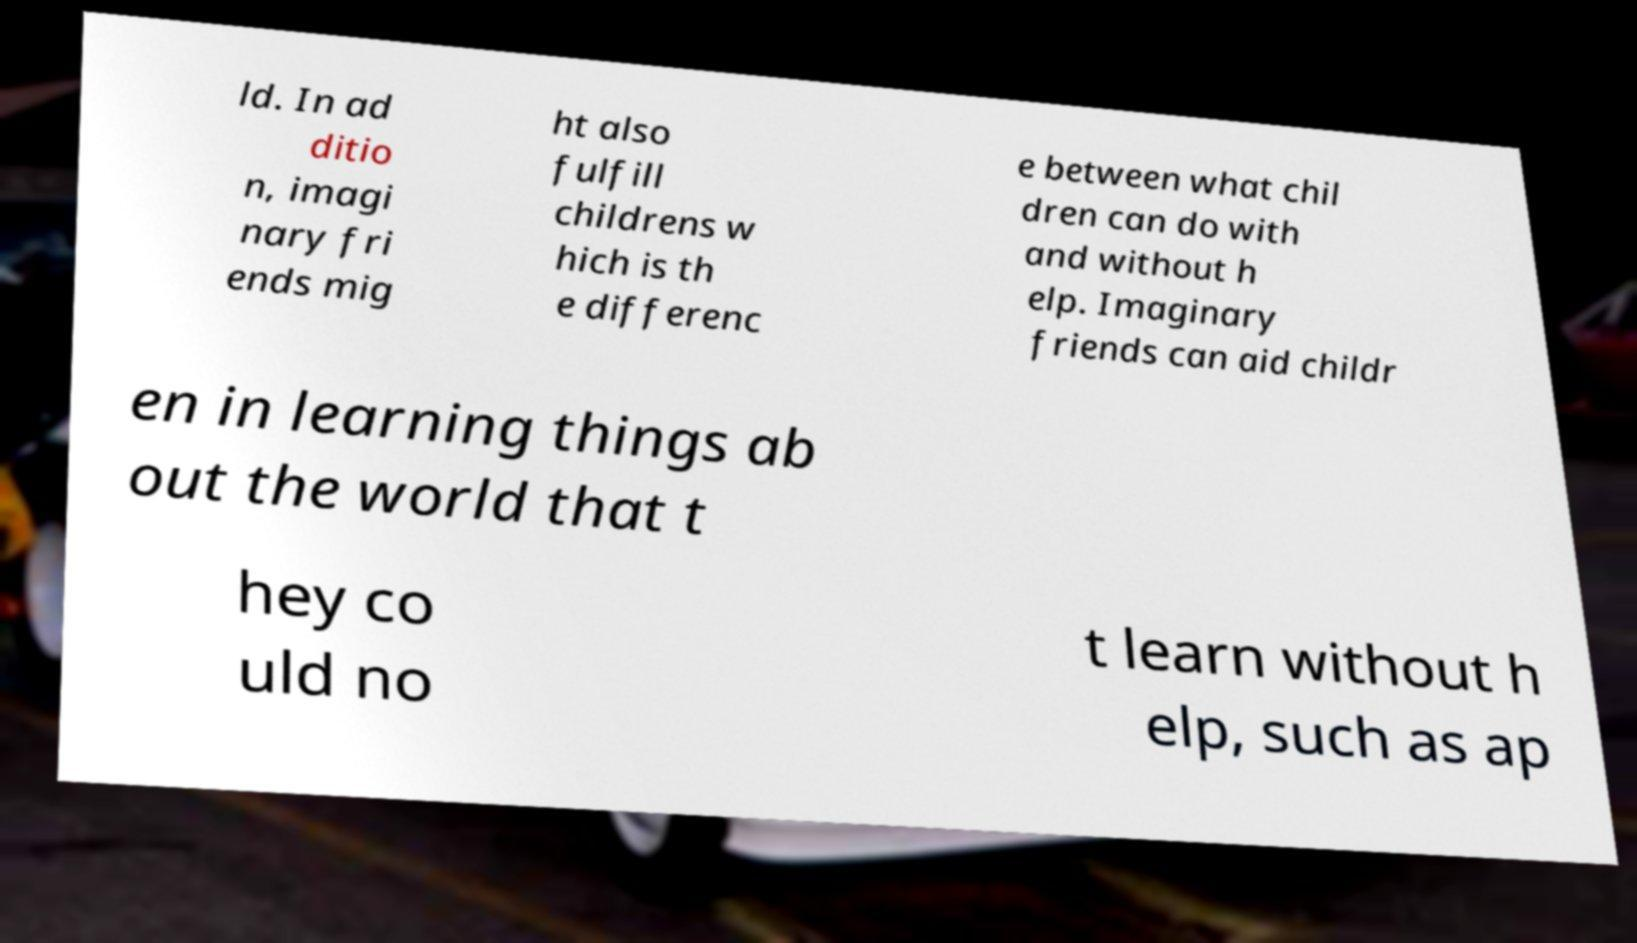Please identify and transcribe the text found in this image. ld. In ad ditio n, imagi nary fri ends mig ht also fulfill childrens w hich is th e differenc e between what chil dren can do with and without h elp. Imaginary friends can aid childr en in learning things ab out the world that t hey co uld no t learn without h elp, such as ap 